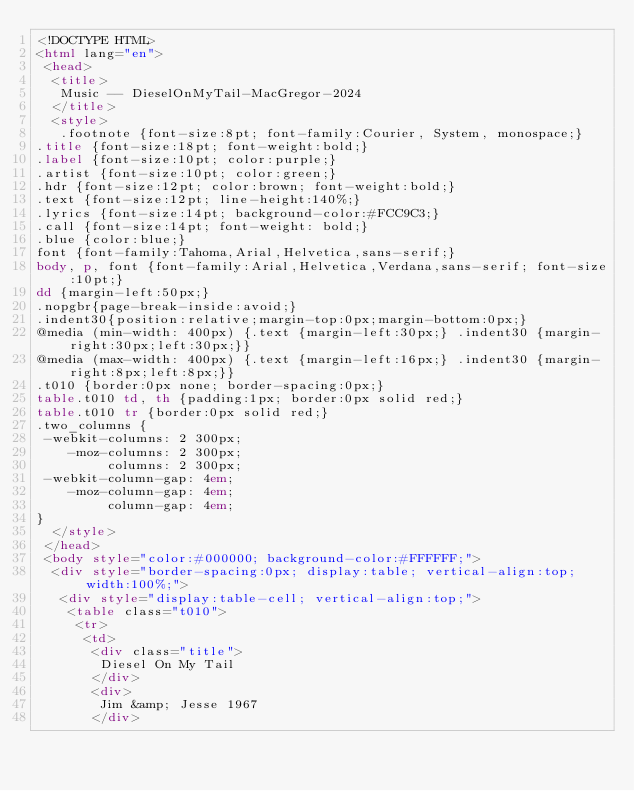Convert code to text. <code><loc_0><loc_0><loc_500><loc_500><_HTML_><!DOCTYPE HTML>
<html lang="en">
 <head>
  <title>
   Music -- DieselOnMyTail-MacGregor-2024
  </title>
  <style>
   .footnote {font-size:8pt; font-family:Courier, System, monospace;}
.title {font-size:18pt; font-weight:bold;}
.label {font-size:10pt; color:purple;}
.artist {font-size:10pt; color:green;}
.hdr {font-size:12pt; color:brown; font-weight:bold;}
.text {font-size:12pt; line-height:140%;}
.lyrics {font-size:14pt; background-color:#FCC9C3;}
.call {font-size:14pt; font-weight: bold;}
.blue {color:blue;}
font {font-family:Tahoma,Arial,Helvetica,sans-serif;}
body, p, font {font-family:Arial,Helvetica,Verdana,sans-serif; font-size:10pt;}
dd {margin-left:50px;}
.nopgbr{page-break-inside:avoid;}
.indent30{position:relative;margin-top:0px;margin-bottom:0px;}
@media (min-width: 400px) {.text {margin-left:30px;} .indent30 {margin-right:30px;left:30px;}}
@media (max-width: 400px) {.text {margin-left:16px;} .indent30 {margin-right:8px;left:8px;}}
.t010 {border:0px none; border-spacing:0px;}
table.t010 td, th {padding:1px; border:0px solid red;}
table.t010 tr {border:0px solid red;}
.two_columns {
 -webkit-columns: 2 300px;
    -moz-columns: 2 300px;
         columns: 2 300px;
 -webkit-column-gap: 4em;
    -moz-column-gap: 4em;
         column-gap: 4em;
}
  </style>
 </head>
 <body style="color:#000000; background-color:#FFFFFF;">
  <div style="border-spacing:0px; display:table; vertical-align:top; width:100%;">
   <div style="display:table-cell; vertical-align:top;">
    <table class="t010">
     <tr>
      <td>
       <div class="title">
        Diesel On My Tail
       </div>
       <div>
        Jim &amp; Jesse 1967
       </div></code> 